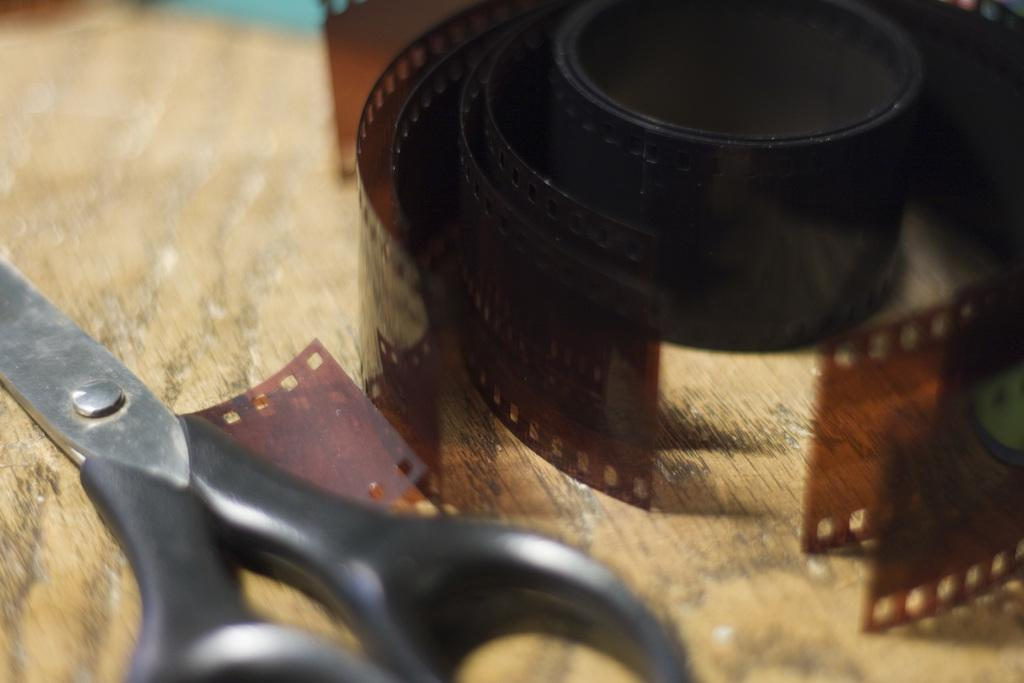What object can be seen in the image that is typically used for storing or organizing items? There is a reel in the image, which is typically used for storing or organizing items. What other object can be seen in the image that is used for cutting? There are scissors in the image, which are used for cutting. Where are the reel and scissors located in the image? Both the reel and scissors are on a table in the image. What type of authority figure can be seen in the image? There is no authority figure present in the image; it only features a reel and scissors on a table. What type of church is depicted in the image? There is no church present in the image; it only features a reel and scissors on a table. 